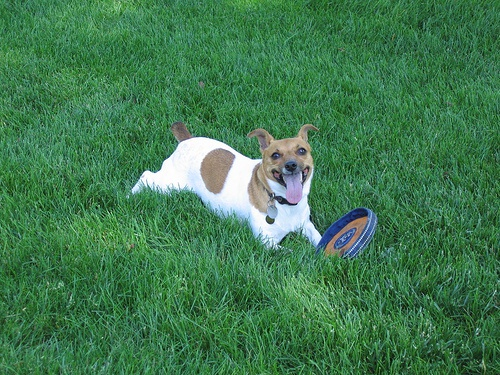Describe the objects in this image and their specific colors. I can see dog in teal, white, darkgray, and gray tones and frisbee in teal, navy, blue, tan, and gray tones in this image. 